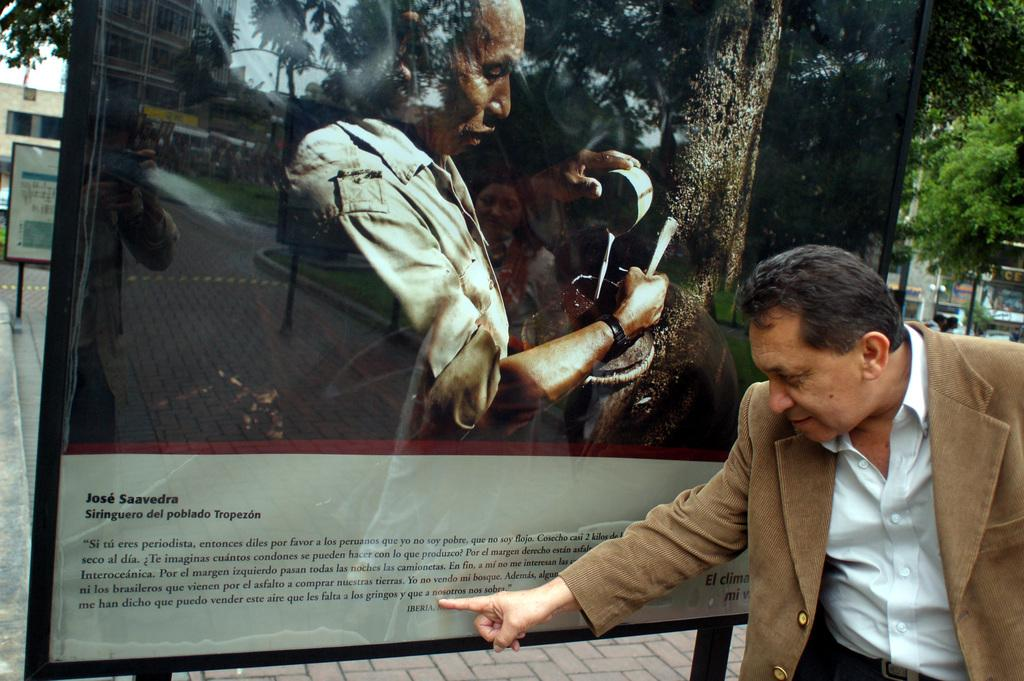Who is present in the image? There is a man in the image. What objects can be seen in the image? There are boards and buildings visible in the image. Can you describe the reflection in the image? There is a reflection of two persons in the image. What type of natural elements can be seen in the image? Trees are visible in the image. What is visible in the background of the image? The sky is visible in the image. Are there any cobwebs visible in the image? There is no mention of cobwebs in the provided facts, so we cannot determine if any are present in the image. Can you describe the action of smashing the boards in the image? There is no action of smashing the boards depicted in the image; the boards are simply present. 